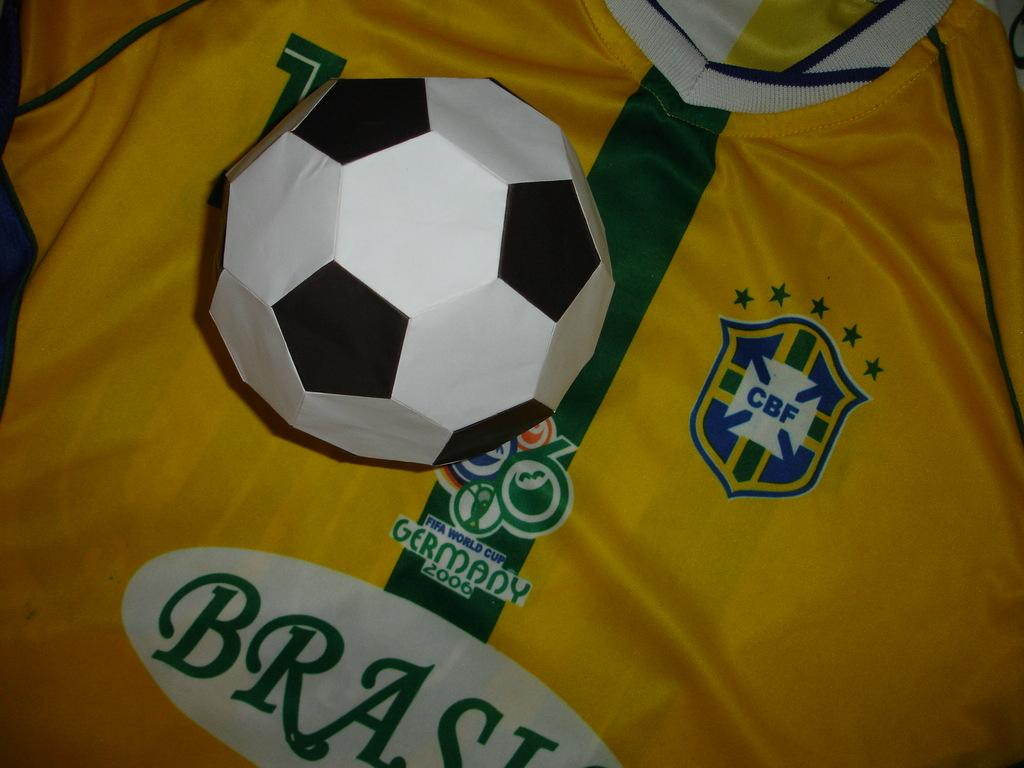<image>
Share a concise interpretation of the image provided. A paper soccer ball rests on a Brazilian jersey. 